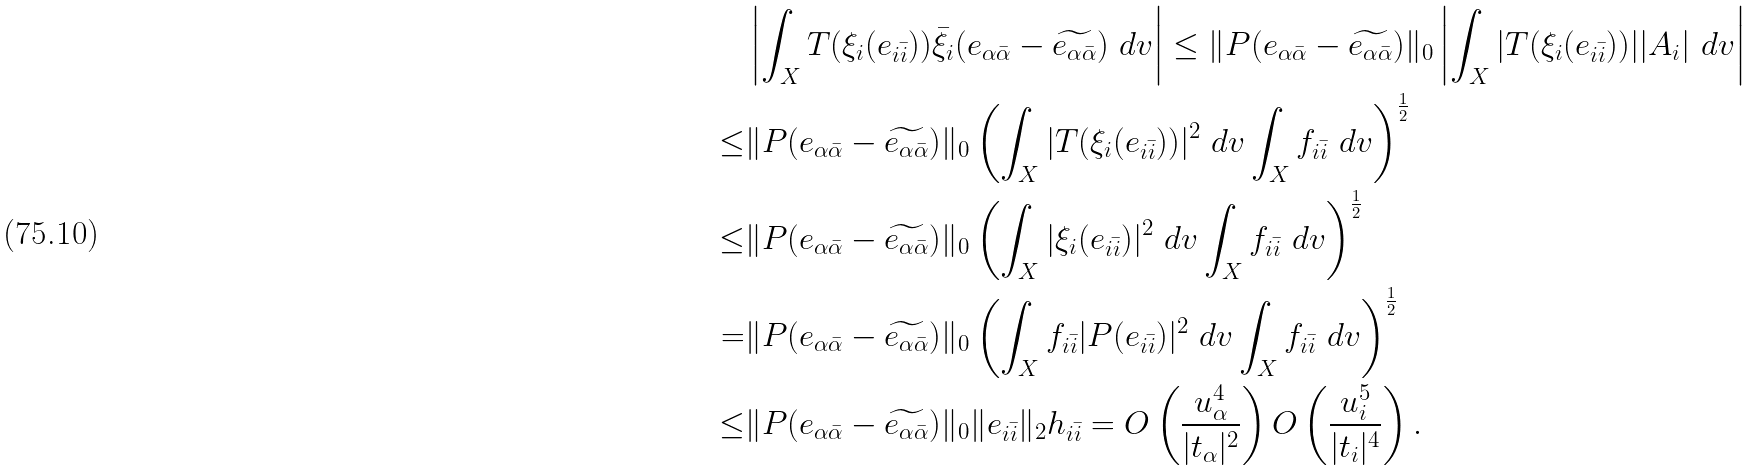Convert formula to latex. <formula><loc_0><loc_0><loc_500><loc_500>& \left | \int _ { X } T ( \xi _ { i } ( e _ { i \bar { i } } ) ) \bar { \xi } _ { i } ( e _ { \alpha \bar { \alpha } } - \widetilde { e _ { \alpha \bar { \alpha } } } ) \ d v \right | \leq \| P ( e _ { \alpha \bar { \alpha } } - \widetilde { e _ { \alpha \bar { \alpha } } } ) \| _ { 0 } \left | \int _ { X } | T ( \xi _ { i } ( e _ { i \bar { i } } ) ) | | A _ { i } | \ d v \right | \\ \leq & \| P ( e _ { \alpha \bar { \alpha } } - \widetilde { e _ { \alpha \bar { \alpha } } } ) \| _ { 0 } \left ( \int _ { X } | T ( \xi _ { i } ( e _ { i \bar { i } } ) ) | ^ { 2 } \ d v \int _ { X } f _ { i \bar { i } } \ d v \right ) ^ { \frac { 1 } { 2 } } \\ \leq & \| P ( e _ { \alpha \bar { \alpha } } - \widetilde { e _ { \alpha \bar { \alpha } } } ) \| _ { 0 } \left ( \int _ { X } | \xi _ { i } ( e _ { i \bar { i } } ) | ^ { 2 } \ d v \int _ { X } f _ { i \bar { i } } \ d v \right ) ^ { \frac { 1 } { 2 } } \\ = & \| P ( e _ { \alpha \bar { \alpha } } - \widetilde { e _ { \alpha \bar { \alpha } } } ) \| _ { 0 } \left ( \int _ { X } f _ { i \bar { i } } | P ( e _ { i \bar { i } } ) | ^ { 2 } \ d v \int _ { X } f _ { i \bar { i } } \ d v \right ) ^ { \frac { 1 } { 2 } } \\ \leq & \| P ( e _ { \alpha \bar { \alpha } } - \widetilde { e _ { \alpha \bar { \alpha } } } ) \| _ { 0 } \| e _ { i \bar { i } } \| _ { 2 } h _ { i \bar { i } } = O \left ( \frac { u _ { \alpha } ^ { 4 } } { | t _ { \alpha } | ^ { 2 } } \right ) O \left ( \frac { u _ { i } ^ { 5 } } { | t _ { i } | ^ { 4 } } \right ) .</formula> 